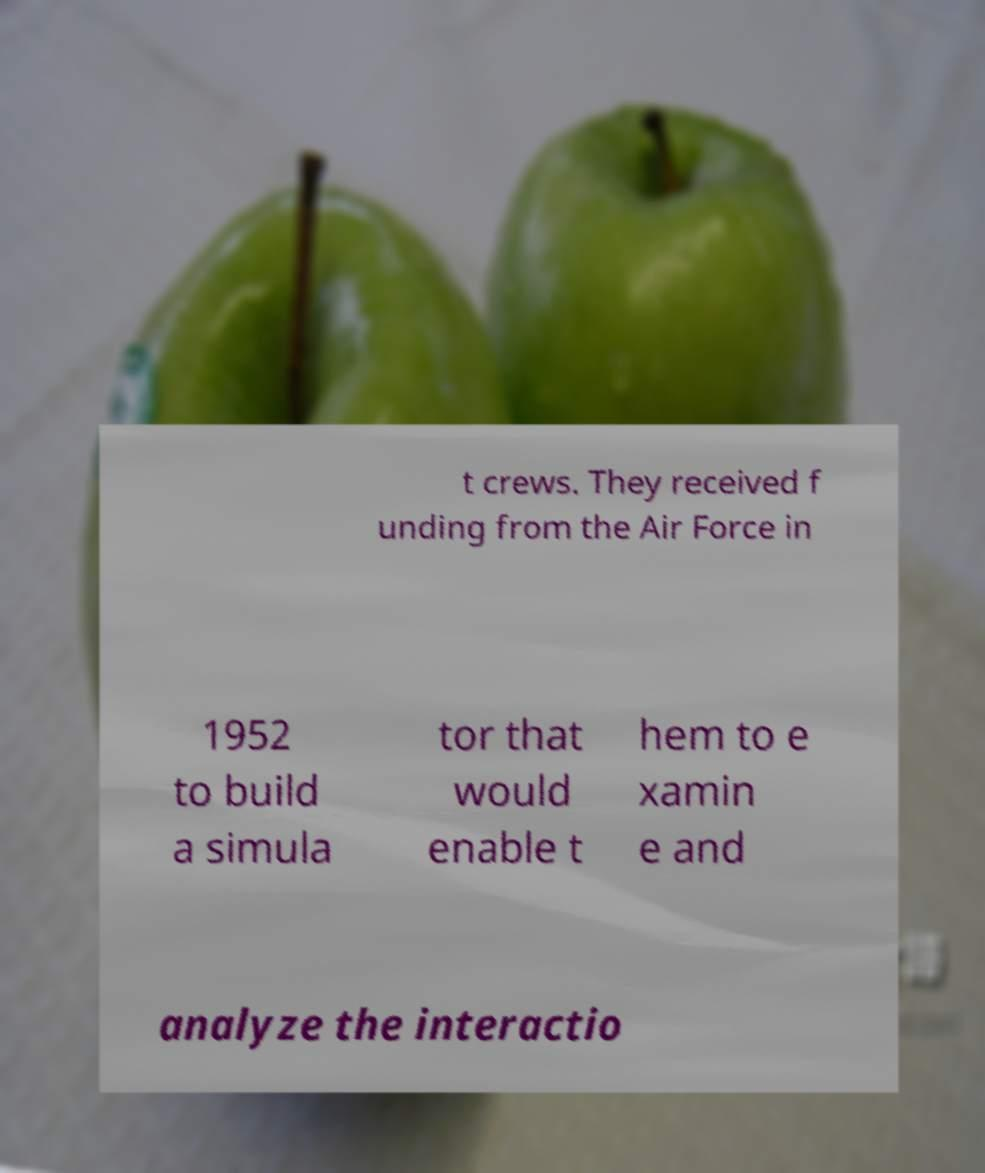Can you accurately transcribe the text from the provided image for me? t crews. They received f unding from the Air Force in 1952 to build a simula tor that would enable t hem to e xamin e and analyze the interactio 